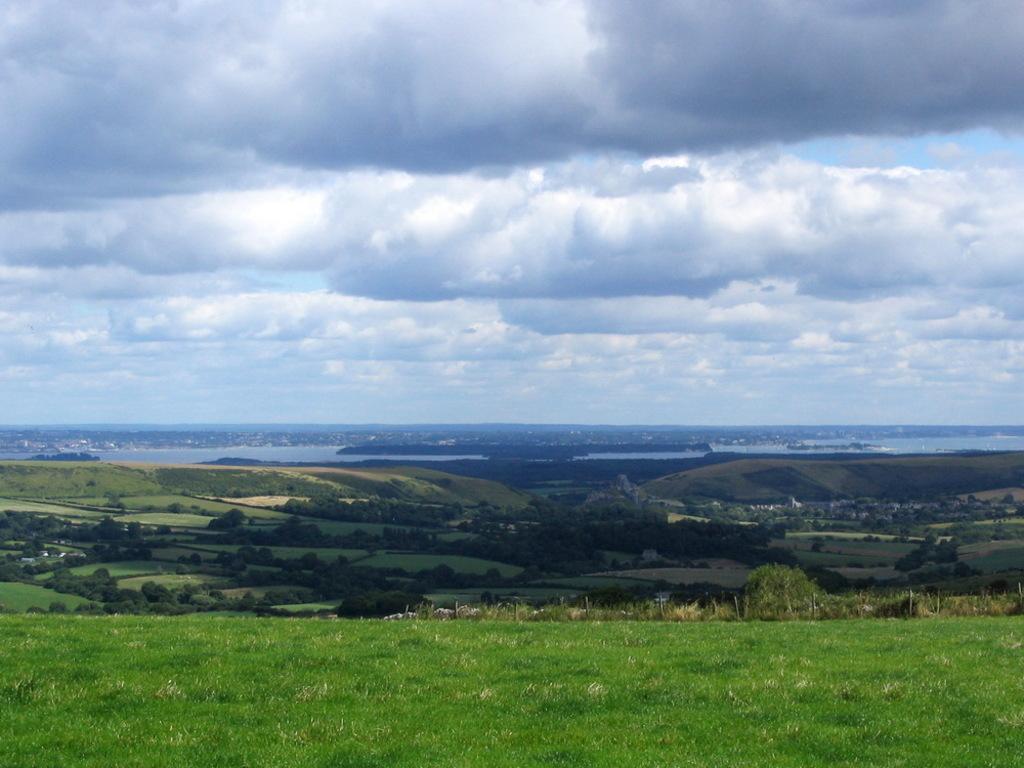Describe this image in one or two sentences. In this image we can see the trees, water and also the sky with the clouds in the background and at the bottom we can see the grass. 